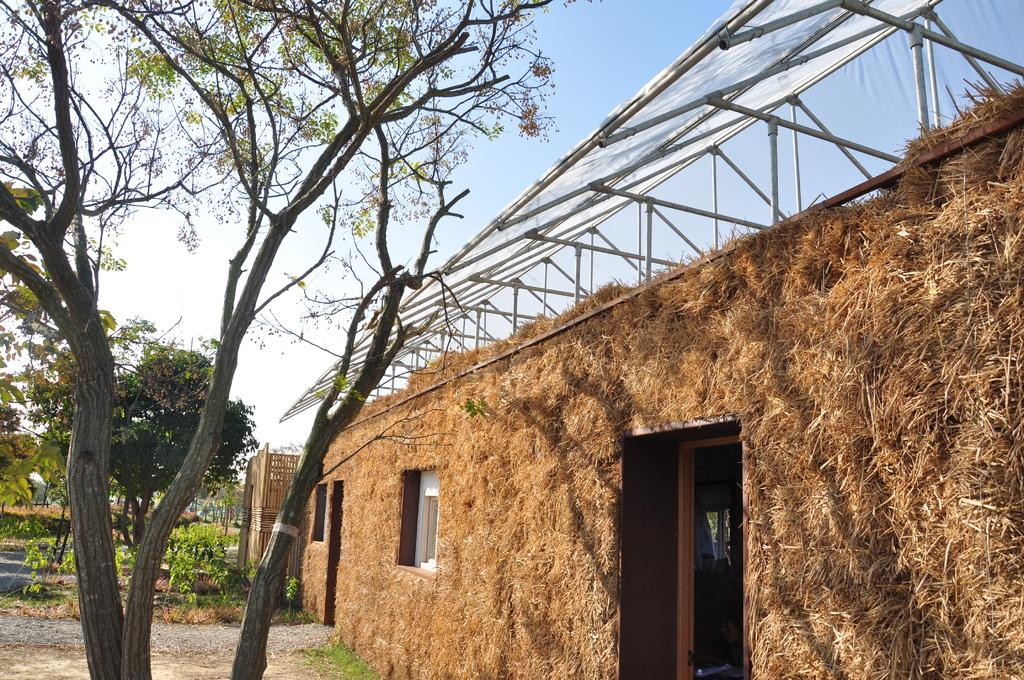What type of vegetation can be seen in the middle of the image? There are trees in the middle of the image. What type of structure is present in the image? There is a house in the image. What is visible in the background of the image? Sky is visible in the image. What type of insect can be seen flying around the house in the image? There is no insect present in the image; it only features trees, a house, and sky. What type of nose can be seen on the house in the image? There is no nose present on the house in the image; it is a structure without facial features. 